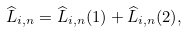<formula> <loc_0><loc_0><loc_500><loc_500>\widehat { L } _ { i , n } = \widehat { L } _ { i , n } ( 1 ) + \widehat { L } _ { i , n } ( 2 ) ,</formula> 